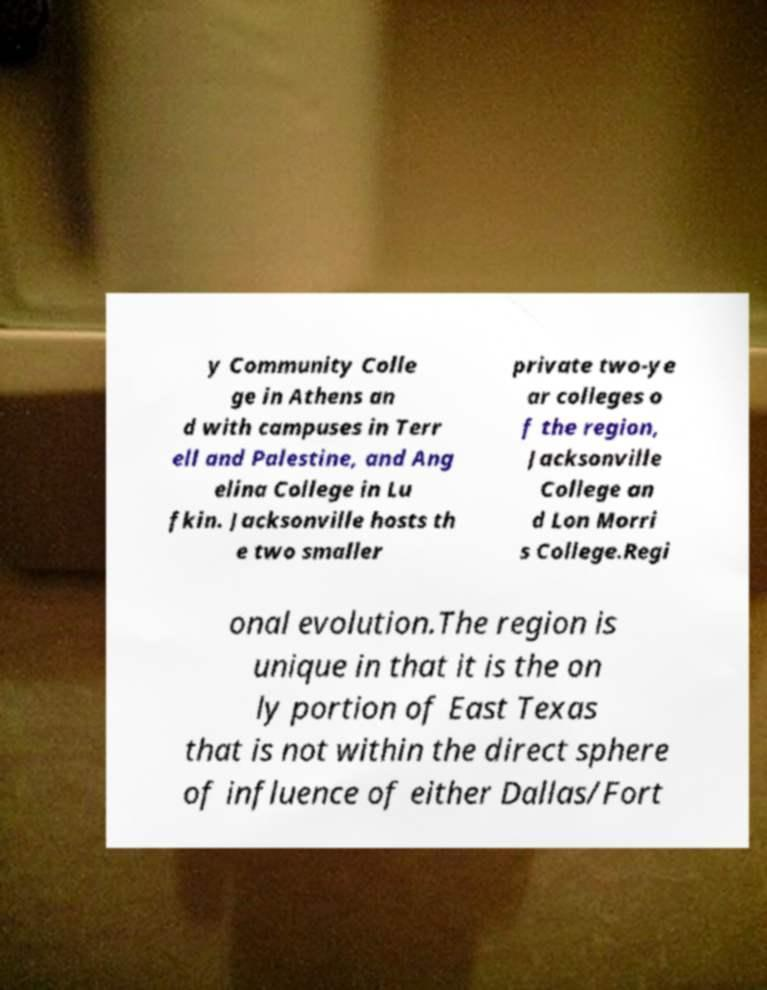There's text embedded in this image that I need extracted. Can you transcribe it verbatim? y Community Colle ge in Athens an d with campuses in Terr ell and Palestine, and Ang elina College in Lu fkin. Jacksonville hosts th e two smaller private two-ye ar colleges o f the region, Jacksonville College an d Lon Morri s College.Regi onal evolution.The region is unique in that it is the on ly portion of East Texas that is not within the direct sphere of influence of either Dallas/Fort 